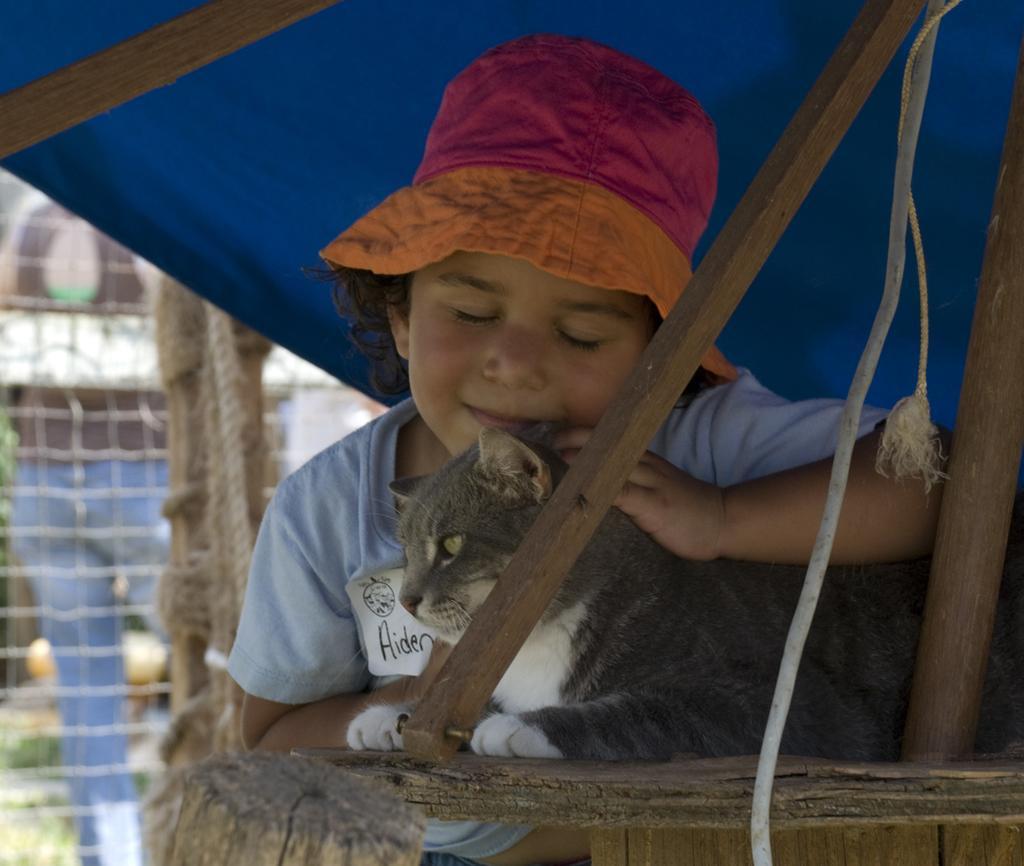Could you give a brief overview of what you see in this image? This picture is clicked outside. In the foreground we can see a kid wearing blue color t-shirt and seems to be standing with his one hand on the cat. The cat is sitting on a wooden plank and we can see the wooden sticks and a blue color tent. In the background we can see the mesh and a person seems to be standing on the ground and we can see many other objects. 